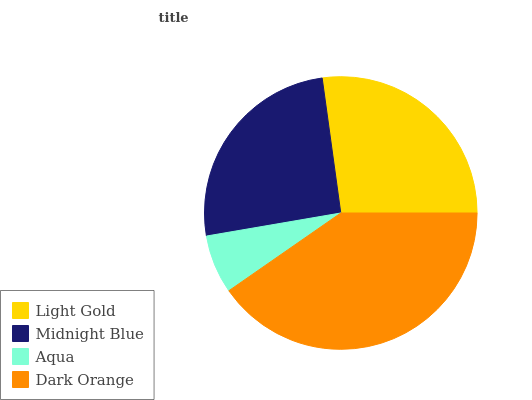Is Aqua the minimum?
Answer yes or no. Yes. Is Dark Orange the maximum?
Answer yes or no. Yes. Is Midnight Blue the minimum?
Answer yes or no. No. Is Midnight Blue the maximum?
Answer yes or no. No. Is Light Gold greater than Midnight Blue?
Answer yes or no. Yes. Is Midnight Blue less than Light Gold?
Answer yes or no. Yes. Is Midnight Blue greater than Light Gold?
Answer yes or no. No. Is Light Gold less than Midnight Blue?
Answer yes or no. No. Is Light Gold the high median?
Answer yes or no. Yes. Is Midnight Blue the low median?
Answer yes or no. Yes. Is Midnight Blue the high median?
Answer yes or no. No. Is Dark Orange the low median?
Answer yes or no. No. 